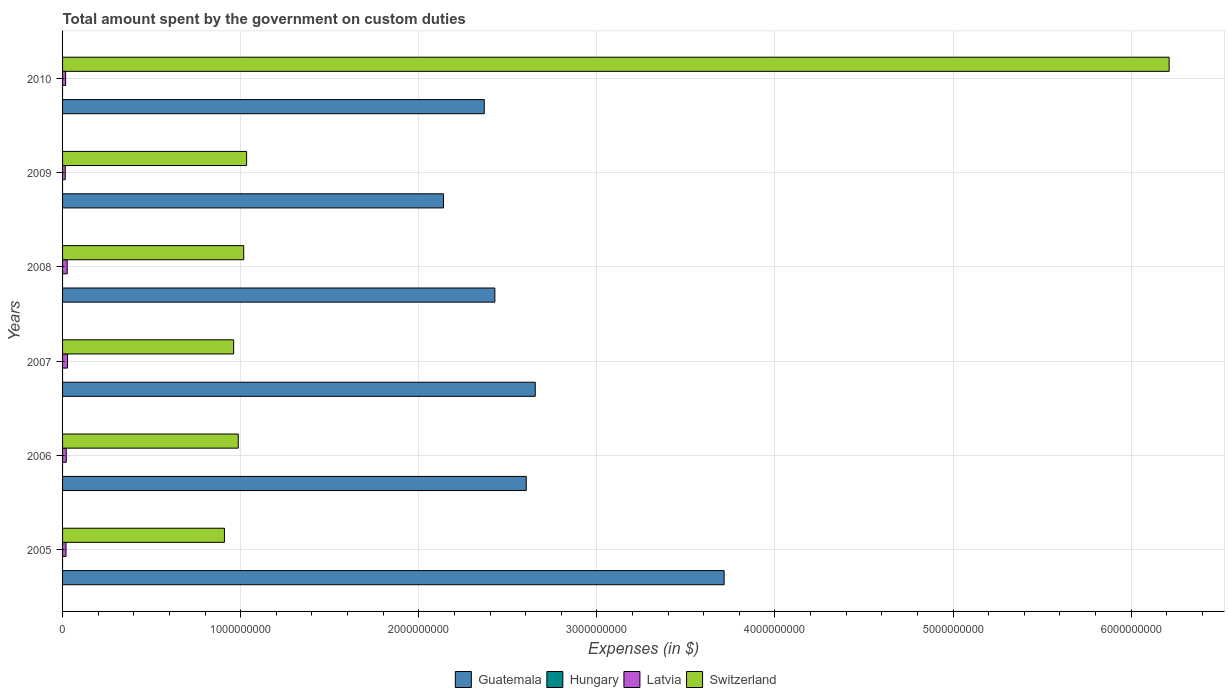How many groups of bars are there?
Provide a succinct answer. 6. Are the number of bars per tick equal to the number of legend labels?
Provide a short and direct response. No. Are the number of bars on each tick of the Y-axis equal?
Make the answer very short. Yes. How many bars are there on the 2nd tick from the top?
Your answer should be compact. 3. How many bars are there on the 6th tick from the bottom?
Offer a terse response. 3. What is the amount spent on custom duties by the government in Guatemala in 2006?
Offer a terse response. 2.60e+09. Across all years, what is the maximum amount spent on custom duties by the government in Switzerland?
Make the answer very short. 6.21e+09. What is the total amount spent on custom duties by the government in Guatemala in the graph?
Offer a terse response. 1.59e+1. What is the difference between the amount spent on custom duties by the government in Switzerland in 2005 and that in 2006?
Your answer should be very brief. -7.76e+07. What is the difference between the amount spent on custom duties by the government in Hungary in 2010 and the amount spent on custom duties by the government in Switzerland in 2007?
Provide a short and direct response. -9.61e+08. In the year 2005, what is the difference between the amount spent on custom duties by the government in Guatemala and amount spent on custom duties by the government in Switzerland?
Your answer should be very brief. 2.81e+09. In how many years, is the amount spent on custom duties by the government in Switzerland greater than 200000000 $?
Your answer should be compact. 6. What is the ratio of the amount spent on custom duties by the government in Guatemala in 2009 to that in 2010?
Keep it short and to the point. 0.9. Is the amount spent on custom duties by the government in Latvia in 2005 less than that in 2006?
Your answer should be very brief. Yes. Is the difference between the amount spent on custom duties by the government in Guatemala in 2009 and 2010 greater than the difference between the amount spent on custom duties by the government in Switzerland in 2009 and 2010?
Your response must be concise. Yes. What is the difference between the highest and the second highest amount spent on custom duties by the government in Latvia?
Make the answer very short. 1.84e+06. What is the difference between the highest and the lowest amount spent on custom duties by the government in Switzerland?
Make the answer very short. 5.30e+09. Is the sum of the amount spent on custom duties by the government in Latvia in 2007 and 2009 greater than the maximum amount spent on custom duties by the government in Guatemala across all years?
Offer a terse response. No. Is it the case that in every year, the sum of the amount spent on custom duties by the government in Switzerland and amount spent on custom duties by the government in Latvia is greater than the sum of amount spent on custom duties by the government in Hungary and amount spent on custom duties by the government in Guatemala?
Your answer should be very brief. No. How many bars are there?
Keep it short and to the point. 18. Are the values on the major ticks of X-axis written in scientific E-notation?
Give a very brief answer. No. Does the graph contain grids?
Provide a succinct answer. Yes. Where does the legend appear in the graph?
Your answer should be very brief. Bottom center. How many legend labels are there?
Keep it short and to the point. 4. What is the title of the graph?
Provide a succinct answer. Total amount spent by the government on custom duties. What is the label or title of the X-axis?
Ensure brevity in your answer.  Expenses (in $). What is the Expenses (in $) of Guatemala in 2005?
Offer a terse response. 3.71e+09. What is the Expenses (in $) of Latvia in 2005?
Provide a succinct answer. 1.92e+07. What is the Expenses (in $) in Switzerland in 2005?
Your answer should be compact. 9.09e+08. What is the Expenses (in $) of Guatemala in 2006?
Provide a short and direct response. 2.60e+09. What is the Expenses (in $) in Latvia in 2006?
Make the answer very short. 2.07e+07. What is the Expenses (in $) of Switzerland in 2006?
Offer a terse response. 9.86e+08. What is the Expenses (in $) in Guatemala in 2007?
Your answer should be very brief. 2.65e+09. What is the Expenses (in $) of Latvia in 2007?
Your answer should be very brief. 2.78e+07. What is the Expenses (in $) in Switzerland in 2007?
Your response must be concise. 9.61e+08. What is the Expenses (in $) in Guatemala in 2008?
Provide a succinct answer. 2.43e+09. What is the Expenses (in $) of Hungary in 2008?
Give a very brief answer. 0. What is the Expenses (in $) of Latvia in 2008?
Provide a succinct answer. 2.60e+07. What is the Expenses (in $) of Switzerland in 2008?
Your answer should be compact. 1.02e+09. What is the Expenses (in $) in Guatemala in 2009?
Offer a terse response. 2.14e+09. What is the Expenses (in $) in Hungary in 2009?
Your answer should be compact. 0. What is the Expenses (in $) of Latvia in 2009?
Offer a very short reply. 1.51e+07. What is the Expenses (in $) in Switzerland in 2009?
Your answer should be compact. 1.03e+09. What is the Expenses (in $) of Guatemala in 2010?
Your answer should be very brief. 2.37e+09. What is the Expenses (in $) in Hungary in 2010?
Make the answer very short. 0. What is the Expenses (in $) of Latvia in 2010?
Make the answer very short. 1.73e+07. What is the Expenses (in $) of Switzerland in 2010?
Make the answer very short. 6.21e+09. Across all years, what is the maximum Expenses (in $) in Guatemala?
Keep it short and to the point. 3.71e+09. Across all years, what is the maximum Expenses (in $) of Latvia?
Keep it short and to the point. 2.78e+07. Across all years, what is the maximum Expenses (in $) of Switzerland?
Offer a terse response. 6.21e+09. Across all years, what is the minimum Expenses (in $) in Guatemala?
Give a very brief answer. 2.14e+09. Across all years, what is the minimum Expenses (in $) of Latvia?
Your response must be concise. 1.51e+07. Across all years, what is the minimum Expenses (in $) in Switzerland?
Ensure brevity in your answer.  9.09e+08. What is the total Expenses (in $) in Guatemala in the graph?
Your response must be concise. 1.59e+1. What is the total Expenses (in $) of Hungary in the graph?
Provide a succinct answer. 0. What is the total Expenses (in $) of Latvia in the graph?
Provide a short and direct response. 1.26e+08. What is the total Expenses (in $) in Switzerland in the graph?
Give a very brief answer. 1.11e+1. What is the difference between the Expenses (in $) in Guatemala in 2005 and that in 2006?
Make the answer very short. 1.11e+09. What is the difference between the Expenses (in $) in Latvia in 2005 and that in 2006?
Keep it short and to the point. -1.50e+06. What is the difference between the Expenses (in $) of Switzerland in 2005 and that in 2006?
Keep it short and to the point. -7.76e+07. What is the difference between the Expenses (in $) of Guatemala in 2005 and that in 2007?
Your answer should be very brief. 1.06e+09. What is the difference between the Expenses (in $) in Latvia in 2005 and that in 2007?
Make the answer very short. -8.64e+06. What is the difference between the Expenses (in $) in Switzerland in 2005 and that in 2007?
Your answer should be very brief. -5.17e+07. What is the difference between the Expenses (in $) in Guatemala in 2005 and that in 2008?
Your answer should be compact. 1.29e+09. What is the difference between the Expenses (in $) of Latvia in 2005 and that in 2008?
Offer a very short reply. -6.80e+06. What is the difference between the Expenses (in $) of Switzerland in 2005 and that in 2008?
Your answer should be very brief. -1.08e+08. What is the difference between the Expenses (in $) in Guatemala in 2005 and that in 2009?
Keep it short and to the point. 1.58e+09. What is the difference between the Expenses (in $) in Latvia in 2005 and that in 2009?
Provide a succinct answer. 4.13e+06. What is the difference between the Expenses (in $) of Switzerland in 2005 and that in 2009?
Your answer should be compact. -1.25e+08. What is the difference between the Expenses (in $) in Guatemala in 2005 and that in 2010?
Your response must be concise. 1.35e+09. What is the difference between the Expenses (in $) in Latvia in 2005 and that in 2010?
Provide a succinct answer. 1.93e+06. What is the difference between the Expenses (in $) in Switzerland in 2005 and that in 2010?
Provide a short and direct response. -5.30e+09. What is the difference between the Expenses (in $) in Guatemala in 2006 and that in 2007?
Your answer should be very brief. -5.04e+07. What is the difference between the Expenses (in $) of Latvia in 2006 and that in 2007?
Your response must be concise. -7.14e+06. What is the difference between the Expenses (in $) in Switzerland in 2006 and that in 2007?
Give a very brief answer. 2.59e+07. What is the difference between the Expenses (in $) in Guatemala in 2006 and that in 2008?
Make the answer very short. 1.76e+08. What is the difference between the Expenses (in $) in Latvia in 2006 and that in 2008?
Provide a short and direct response. -5.30e+06. What is the difference between the Expenses (in $) of Switzerland in 2006 and that in 2008?
Offer a terse response. -3.07e+07. What is the difference between the Expenses (in $) in Guatemala in 2006 and that in 2009?
Offer a terse response. 4.65e+08. What is the difference between the Expenses (in $) in Latvia in 2006 and that in 2009?
Offer a very short reply. 5.63e+06. What is the difference between the Expenses (in $) in Switzerland in 2006 and that in 2009?
Your answer should be very brief. -4.70e+07. What is the difference between the Expenses (in $) of Guatemala in 2006 and that in 2010?
Your response must be concise. 2.36e+08. What is the difference between the Expenses (in $) in Latvia in 2006 and that in 2010?
Provide a short and direct response. 3.43e+06. What is the difference between the Expenses (in $) of Switzerland in 2006 and that in 2010?
Keep it short and to the point. -5.23e+09. What is the difference between the Expenses (in $) of Guatemala in 2007 and that in 2008?
Your answer should be compact. 2.27e+08. What is the difference between the Expenses (in $) in Latvia in 2007 and that in 2008?
Provide a succinct answer. 1.84e+06. What is the difference between the Expenses (in $) in Switzerland in 2007 and that in 2008?
Offer a terse response. -5.66e+07. What is the difference between the Expenses (in $) in Guatemala in 2007 and that in 2009?
Give a very brief answer. 5.15e+08. What is the difference between the Expenses (in $) in Latvia in 2007 and that in 2009?
Your answer should be very brief. 1.28e+07. What is the difference between the Expenses (in $) of Switzerland in 2007 and that in 2009?
Ensure brevity in your answer.  -7.29e+07. What is the difference between the Expenses (in $) in Guatemala in 2007 and that in 2010?
Offer a very short reply. 2.86e+08. What is the difference between the Expenses (in $) in Latvia in 2007 and that in 2010?
Your answer should be very brief. 1.06e+07. What is the difference between the Expenses (in $) of Switzerland in 2007 and that in 2010?
Provide a short and direct response. -5.25e+09. What is the difference between the Expenses (in $) of Guatemala in 2008 and that in 2009?
Keep it short and to the point. 2.88e+08. What is the difference between the Expenses (in $) in Latvia in 2008 and that in 2009?
Provide a short and direct response. 1.09e+07. What is the difference between the Expenses (in $) in Switzerland in 2008 and that in 2009?
Give a very brief answer. -1.63e+07. What is the difference between the Expenses (in $) of Guatemala in 2008 and that in 2010?
Make the answer very short. 5.95e+07. What is the difference between the Expenses (in $) in Latvia in 2008 and that in 2010?
Keep it short and to the point. 8.73e+06. What is the difference between the Expenses (in $) in Switzerland in 2008 and that in 2010?
Your answer should be very brief. -5.20e+09. What is the difference between the Expenses (in $) in Guatemala in 2009 and that in 2010?
Offer a terse response. -2.29e+08. What is the difference between the Expenses (in $) in Latvia in 2009 and that in 2010?
Offer a terse response. -2.20e+06. What is the difference between the Expenses (in $) of Switzerland in 2009 and that in 2010?
Your answer should be compact. -5.18e+09. What is the difference between the Expenses (in $) in Guatemala in 2005 and the Expenses (in $) in Latvia in 2006?
Provide a succinct answer. 3.69e+09. What is the difference between the Expenses (in $) in Guatemala in 2005 and the Expenses (in $) in Switzerland in 2006?
Your response must be concise. 2.73e+09. What is the difference between the Expenses (in $) in Latvia in 2005 and the Expenses (in $) in Switzerland in 2006?
Provide a short and direct response. -9.67e+08. What is the difference between the Expenses (in $) of Guatemala in 2005 and the Expenses (in $) of Latvia in 2007?
Make the answer very short. 3.69e+09. What is the difference between the Expenses (in $) of Guatemala in 2005 and the Expenses (in $) of Switzerland in 2007?
Make the answer very short. 2.75e+09. What is the difference between the Expenses (in $) in Latvia in 2005 and the Expenses (in $) in Switzerland in 2007?
Ensure brevity in your answer.  -9.41e+08. What is the difference between the Expenses (in $) of Guatemala in 2005 and the Expenses (in $) of Latvia in 2008?
Keep it short and to the point. 3.69e+09. What is the difference between the Expenses (in $) in Guatemala in 2005 and the Expenses (in $) in Switzerland in 2008?
Give a very brief answer. 2.70e+09. What is the difference between the Expenses (in $) of Latvia in 2005 and the Expenses (in $) of Switzerland in 2008?
Offer a terse response. -9.98e+08. What is the difference between the Expenses (in $) in Guatemala in 2005 and the Expenses (in $) in Latvia in 2009?
Offer a terse response. 3.70e+09. What is the difference between the Expenses (in $) of Guatemala in 2005 and the Expenses (in $) of Switzerland in 2009?
Offer a very short reply. 2.68e+09. What is the difference between the Expenses (in $) of Latvia in 2005 and the Expenses (in $) of Switzerland in 2009?
Offer a very short reply. -1.01e+09. What is the difference between the Expenses (in $) of Guatemala in 2005 and the Expenses (in $) of Latvia in 2010?
Give a very brief answer. 3.70e+09. What is the difference between the Expenses (in $) in Guatemala in 2005 and the Expenses (in $) in Switzerland in 2010?
Offer a terse response. -2.50e+09. What is the difference between the Expenses (in $) in Latvia in 2005 and the Expenses (in $) in Switzerland in 2010?
Offer a terse response. -6.19e+09. What is the difference between the Expenses (in $) of Guatemala in 2006 and the Expenses (in $) of Latvia in 2007?
Provide a succinct answer. 2.58e+09. What is the difference between the Expenses (in $) of Guatemala in 2006 and the Expenses (in $) of Switzerland in 2007?
Your response must be concise. 1.64e+09. What is the difference between the Expenses (in $) of Latvia in 2006 and the Expenses (in $) of Switzerland in 2007?
Offer a terse response. -9.40e+08. What is the difference between the Expenses (in $) in Guatemala in 2006 and the Expenses (in $) in Latvia in 2008?
Keep it short and to the point. 2.58e+09. What is the difference between the Expenses (in $) in Guatemala in 2006 and the Expenses (in $) in Switzerland in 2008?
Your answer should be compact. 1.59e+09. What is the difference between the Expenses (in $) of Latvia in 2006 and the Expenses (in $) of Switzerland in 2008?
Make the answer very short. -9.96e+08. What is the difference between the Expenses (in $) in Guatemala in 2006 and the Expenses (in $) in Latvia in 2009?
Your response must be concise. 2.59e+09. What is the difference between the Expenses (in $) in Guatemala in 2006 and the Expenses (in $) in Switzerland in 2009?
Your answer should be compact. 1.57e+09. What is the difference between the Expenses (in $) of Latvia in 2006 and the Expenses (in $) of Switzerland in 2009?
Give a very brief answer. -1.01e+09. What is the difference between the Expenses (in $) of Guatemala in 2006 and the Expenses (in $) of Latvia in 2010?
Offer a terse response. 2.59e+09. What is the difference between the Expenses (in $) of Guatemala in 2006 and the Expenses (in $) of Switzerland in 2010?
Offer a very short reply. -3.61e+09. What is the difference between the Expenses (in $) of Latvia in 2006 and the Expenses (in $) of Switzerland in 2010?
Your answer should be compact. -6.19e+09. What is the difference between the Expenses (in $) in Guatemala in 2007 and the Expenses (in $) in Latvia in 2008?
Provide a short and direct response. 2.63e+09. What is the difference between the Expenses (in $) in Guatemala in 2007 and the Expenses (in $) in Switzerland in 2008?
Provide a succinct answer. 1.64e+09. What is the difference between the Expenses (in $) of Latvia in 2007 and the Expenses (in $) of Switzerland in 2008?
Offer a terse response. -9.89e+08. What is the difference between the Expenses (in $) of Guatemala in 2007 and the Expenses (in $) of Latvia in 2009?
Offer a terse response. 2.64e+09. What is the difference between the Expenses (in $) of Guatemala in 2007 and the Expenses (in $) of Switzerland in 2009?
Provide a short and direct response. 1.62e+09. What is the difference between the Expenses (in $) of Latvia in 2007 and the Expenses (in $) of Switzerland in 2009?
Offer a very short reply. -1.01e+09. What is the difference between the Expenses (in $) of Guatemala in 2007 and the Expenses (in $) of Latvia in 2010?
Give a very brief answer. 2.64e+09. What is the difference between the Expenses (in $) in Guatemala in 2007 and the Expenses (in $) in Switzerland in 2010?
Your response must be concise. -3.56e+09. What is the difference between the Expenses (in $) in Latvia in 2007 and the Expenses (in $) in Switzerland in 2010?
Your answer should be very brief. -6.19e+09. What is the difference between the Expenses (in $) of Guatemala in 2008 and the Expenses (in $) of Latvia in 2009?
Your answer should be very brief. 2.41e+09. What is the difference between the Expenses (in $) of Guatemala in 2008 and the Expenses (in $) of Switzerland in 2009?
Provide a succinct answer. 1.39e+09. What is the difference between the Expenses (in $) of Latvia in 2008 and the Expenses (in $) of Switzerland in 2009?
Keep it short and to the point. -1.01e+09. What is the difference between the Expenses (in $) of Guatemala in 2008 and the Expenses (in $) of Latvia in 2010?
Ensure brevity in your answer.  2.41e+09. What is the difference between the Expenses (in $) of Guatemala in 2008 and the Expenses (in $) of Switzerland in 2010?
Your response must be concise. -3.79e+09. What is the difference between the Expenses (in $) of Latvia in 2008 and the Expenses (in $) of Switzerland in 2010?
Keep it short and to the point. -6.19e+09. What is the difference between the Expenses (in $) of Guatemala in 2009 and the Expenses (in $) of Latvia in 2010?
Make the answer very short. 2.12e+09. What is the difference between the Expenses (in $) of Guatemala in 2009 and the Expenses (in $) of Switzerland in 2010?
Give a very brief answer. -4.07e+09. What is the difference between the Expenses (in $) of Latvia in 2009 and the Expenses (in $) of Switzerland in 2010?
Make the answer very short. -6.20e+09. What is the average Expenses (in $) of Guatemala per year?
Your answer should be compact. 2.65e+09. What is the average Expenses (in $) in Latvia per year?
Provide a succinct answer. 2.10e+07. What is the average Expenses (in $) in Switzerland per year?
Offer a terse response. 1.85e+09. In the year 2005, what is the difference between the Expenses (in $) of Guatemala and Expenses (in $) of Latvia?
Your response must be concise. 3.70e+09. In the year 2005, what is the difference between the Expenses (in $) in Guatemala and Expenses (in $) in Switzerland?
Provide a short and direct response. 2.81e+09. In the year 2005, what is the difference between the Expenses (in $) in Latvia and Expenses (in $) in Switzerland?
Provide a short and direct response. -8.90e+08. In the year 2006, what is the difference between the Expenses (in $) in Guatemala and Expenses (in $) in Latvia?
Your answer should be very brief. 2.58e+09. In the year 2006, what is the difference between the Expenses (in $) in Guatemala and Expenses (in $) in Switzerland?
Offer a very short reply. 1.62e+09. In the year 2006, what is the difference between the Expenses (in $) of Latvia and Expenses (in $) of Switzerland?
Your answer should be very brief. -9.66e+08. In the year 2007, what is the difference between the Expenses (in $) of Guatemala and Expenses (in $) of Latvia?
Provide a short and direct response. 2.63e+09. In the year 2007, what is the difference between the Expenses (in $) of Guatemala and Expenses (in $) of Switzerland?
Keep it short and to the point. 1.69e+09. In the year 2007, what is the difference between the Expenses (in $) of Latvia and Expenses (in $) of Switzerland?
Provide a short and direct response. -9.33e+08. In the year 2008, what is the difference between the Expenses (in $) in Guatemala and Expenses (in $) in Latvia?
Provide a short and direct response. 2.40e+09. In the year 2008, what is the difference between the Expenses (in $) of Guatemala and Expenses (in $) of Switzerland?
Offer a terse response. 1.41e+09. In the year 2008, what is the difference between the Expenses (in $) in Latvia and Expenses (in $) in Switzerland?
Offer a very short reply. -9.91e+08. In the year 2009, what is the difference between the Expenses (in $) in Guatemala and Expenses (in $) in Latvia?
Give a very brief answer. 2.12e+09. In the year 2009, what is the difference between the Expenses (in $) of Guatemala and Expenses (in $) of Switzerland?
Your answer should be very brief. 1.11e+09. In the year 2009, what is the difference between the Expenses (in $) of Latvia and Expenses (in $) of Switzerland?
Your response must be concise. -1.02e+09. In the year 2010, what is the difference between the Expenses (in $) of Guatemala and Expenses (in $) of Latvia?
Offer a very short reply. 2.35e+09. In the year 2010, what is the difference between the Expenses (in $) in Guatemala and Expenses (in $) in Switzerland?
Keep it short and to the point. -3.85e+09. In the year 2010, what is the difference between the Expenses (in $) in Latvia and Expenses (in $) in Switzerland?
Your response must be concise. -6.20e+09. What is the ratio of the Expenses (in $) of Guatemala in 2005 to that in 2006?
Ensure brevity in your answer.  1.43. What is the ratio of the Expenses (in $) of Latvia in 2005 to that in 2006?
Provide a short and direct response. 0.93. What is the ratio of the Expenses (in $) of Switzerland in 2005 to that in 2006?
Provide a short and direct response. 0.92. What is the ratio of the Expenses (in $) in Guatemala in 2005 to that in 2007?
Provide a short and direct response. 1.4. What is the ratio of the Expenses (in $) in Latvia in 2005 to that in 2007?
Ensure brevity in your answer.  0.69. What is the ratio of the Expenses (in $) in Switzerland in 2005 to that in 2007?
Give a very brief answer. 0.95. What is the ratio of the Expenses (in $) in Guatemala in 2005 to that in 2008?
Your response must be concise. 1.53. What is the ratio of the Expenses (in $) in Latvia in 2005 to that in 2008?
Your response must be concise. 0.74. What is the ratio of the Expenses (in $) in Switzerland in 2005 to that in 2008?
Provide a short and direct response. 0.89. What is the ratio of the Expenses (in $) of Guatemala in 2005 to that in 2009?
Offer a very short reply. 1.74. What is the ratio of the Expenses (in $) in Latvia in 2005 to that in 2009?
Provide a short and direct response. 1.27. What is the ratio of the Expenses (in $) of Switzerland in 2005 to that in 2009?
Make the answer very short. 0.88. What is the ratio of the Expenses (in $) in Guatemala in 2005 to that in 2010?
Make the answer very short. 1.57. What is the ratio of the Expenses (in $) in Latvia in 2005 to that in 2010?
Give a very brief answer. 1.11. What is the ratio of the Expenses (in $) of Switzerland in 2005 to that in 2010?
Provide a short and direct response. 0.15. What is the ratio of the Expenses (in $) of Latvia in 2006 to that in 2007?
Your answer should be very brief. 0.74. What is the ratio of the Expenses (in $) in Guatemala in 2006 to that in 2008?
Make the answer very short. 1.07. What is the ratio of the Expenses (in $) of Latvia in 2006 to that in 2008?
Provide a succinct answer. 0.8. What is the ratio of the Expenses (in $) in Switzerland in 2006 to that in 2008?
Your response must be concise. 0.97. What is the ratio of the Expenses (in $) of Guatemala in 2006 to that in 2009?
Make the answer very short. 1.22. What is the ratio of the Expenses (in $) of Latvia in 2006 to that in 2009?
Offer a very short reply. 1.37. What is the ratio of the Expenses (in $) in Switzerland in 2006 to that in 2009?
Ensure brevity in your answer.  0.95. What is the ratio of the Expenses (in $) of Guatemala in 2006 to that in 2010?
Ensure brevity in your answer.  1.1. What is the ratio of the Expenses (in $) of Latvia in 2006 to that in 2010?
Your answer should be very brief. 1.2. What is the ratio of the Expenses (in $) in Switzerland in 2006 to that in 2010?
Keep it short and to the point. 0.16. What is the ratio of the Expenses (in $) in Guatemala in 2007 to that in 2008?
Provide a short and direct response. 1.09. What is the ratio of the Expenses (in $) in Latvia in 2007 to that in 2008?
Your answer should be very brief. 1.07. What is the ratio of the Expenses (in $) in Guatemala in 2007 to that in 2009?
Provide a short and direct response. 1.24. What is the ratio of the Expenses (in $) in Latvia in 2007 to that in 2009?
Make the answer very short. 1.85. What is the ratio of the Expenses (in $) of Switzerland in 2007 to that in 2009?
Make the answer very short. 0.93. What is the ratio of the Expenses (in $) in Guatemala in 2007 to that in 2010?
Your response must be concise. 1.12. What is the ratio of the Expenses (in $) in Latvia in 2007 to that in 2010?
Provide a succinct answer. 1.61. What is the ratio of the Expenses (in $) in Switzerland in 2007 to that in 2010?
Provide a short and direct response. 0.15. What is the ratio of the Expenses (in $) in Guatemala in 2008 to that in 2009?
Keep it short and to the point. 1.13. What is the ratio of the Expenses (in $) of Latvia in 2008 to that in 2009?
Give a very brief answer. 1.73. What is the ratio of the Expenses (in $) of Switzerland in 2008 to that in 2009?
Provide a short and direct response. 0.98. What is the ratio of the Expenses (in $) in Guatemala in 2008 to that in 2010?
Ensure brevity in your answer.  1.03. What is the ratio of the Expenses (in $) in Latvia in 2008 to that in 2010?
Your response must be concise. 1.51. What is the ratio of the Expenses (in $) in Switzerland in 2008 to that in 2010?
Your answer should be very brief. 0.16. What is the ratio of the Expenses (in $) in Guatemala in 2009 to that in 2010?
Keep it short and to the point. 0.9. What is the ratio of the Expenses (in $) in Latvia in 2009 to that in 2010?
Give a very brief answer. 0.87. What is the ratio of the Expenses (in $) in Switzerland in 2009 to that in 2010?
Your answer should be compact. 0.17. What is the difference between the highest and the second highest Expenses (in $) of Guatemala?
Your answer should be very brief. 1.06e+09. What is the difference between the highest and the second highest Expenses (in $) in Latvia?
Your answer should be compact. 1.84e+06. What is the difference between the highest and the second highest Expenses (in $) in Switzerland?
Your response must be concise. 5.18e+09. What is the difference between the highest and the lowest Expenses (in $) of Guatemala?
Your response must be concise. 1.58e+09. What is the difference between the highest and the lowest Expenses (in $) of Latvia?
Offer a terse response. 1.28e+07. What is the difference between the highest and the lowest Expenses (in $) of Switzerland?
Your answer should be very brief. 5.30e+09. 